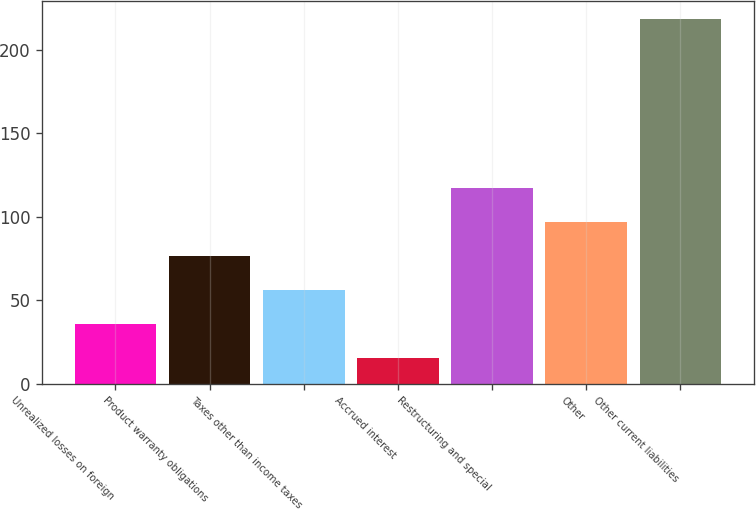Convert chart. <chart><loc_0><loc_0><loc_500><loc_500><bar_chart><fcel>Unrealized losses on foreign<fcel>Product warranty obligations<fcel>Taxes other than income taxes<fcel>Accrued interest<fcel>Restructuring and special<fcel>Other<fcel>Other current liabilities<nl><fcel>35.9<fcel>76.5<fcel>56.2<fcel>15.6<fcel>117.1<fcel>96.8<fcel>218.6<nl></chart> 